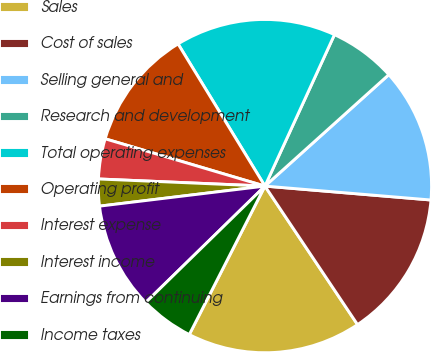Convert chart. <chart><loc_0><loc_0><loc_500><loc_500><pie_chart><fcel>Sales<fcel>Cost of sales<fcel>Selling general and<fcel>Research and development<fcel>Total operating expenses<fcel>Operating profit<fcel>Interest expense<fcel>Interest income<fcel>Earnings from continuing<fcel>Income taxes<nl><fcel>16.88%<fcel>14.29%<fcel>12.99%<fcel>6.49%<fcel>15.58%<fcel>11.69%<fcel>3.9%<fcel>2.6%<fcel>10.39%<fcel>5.19%<nl></chart> 